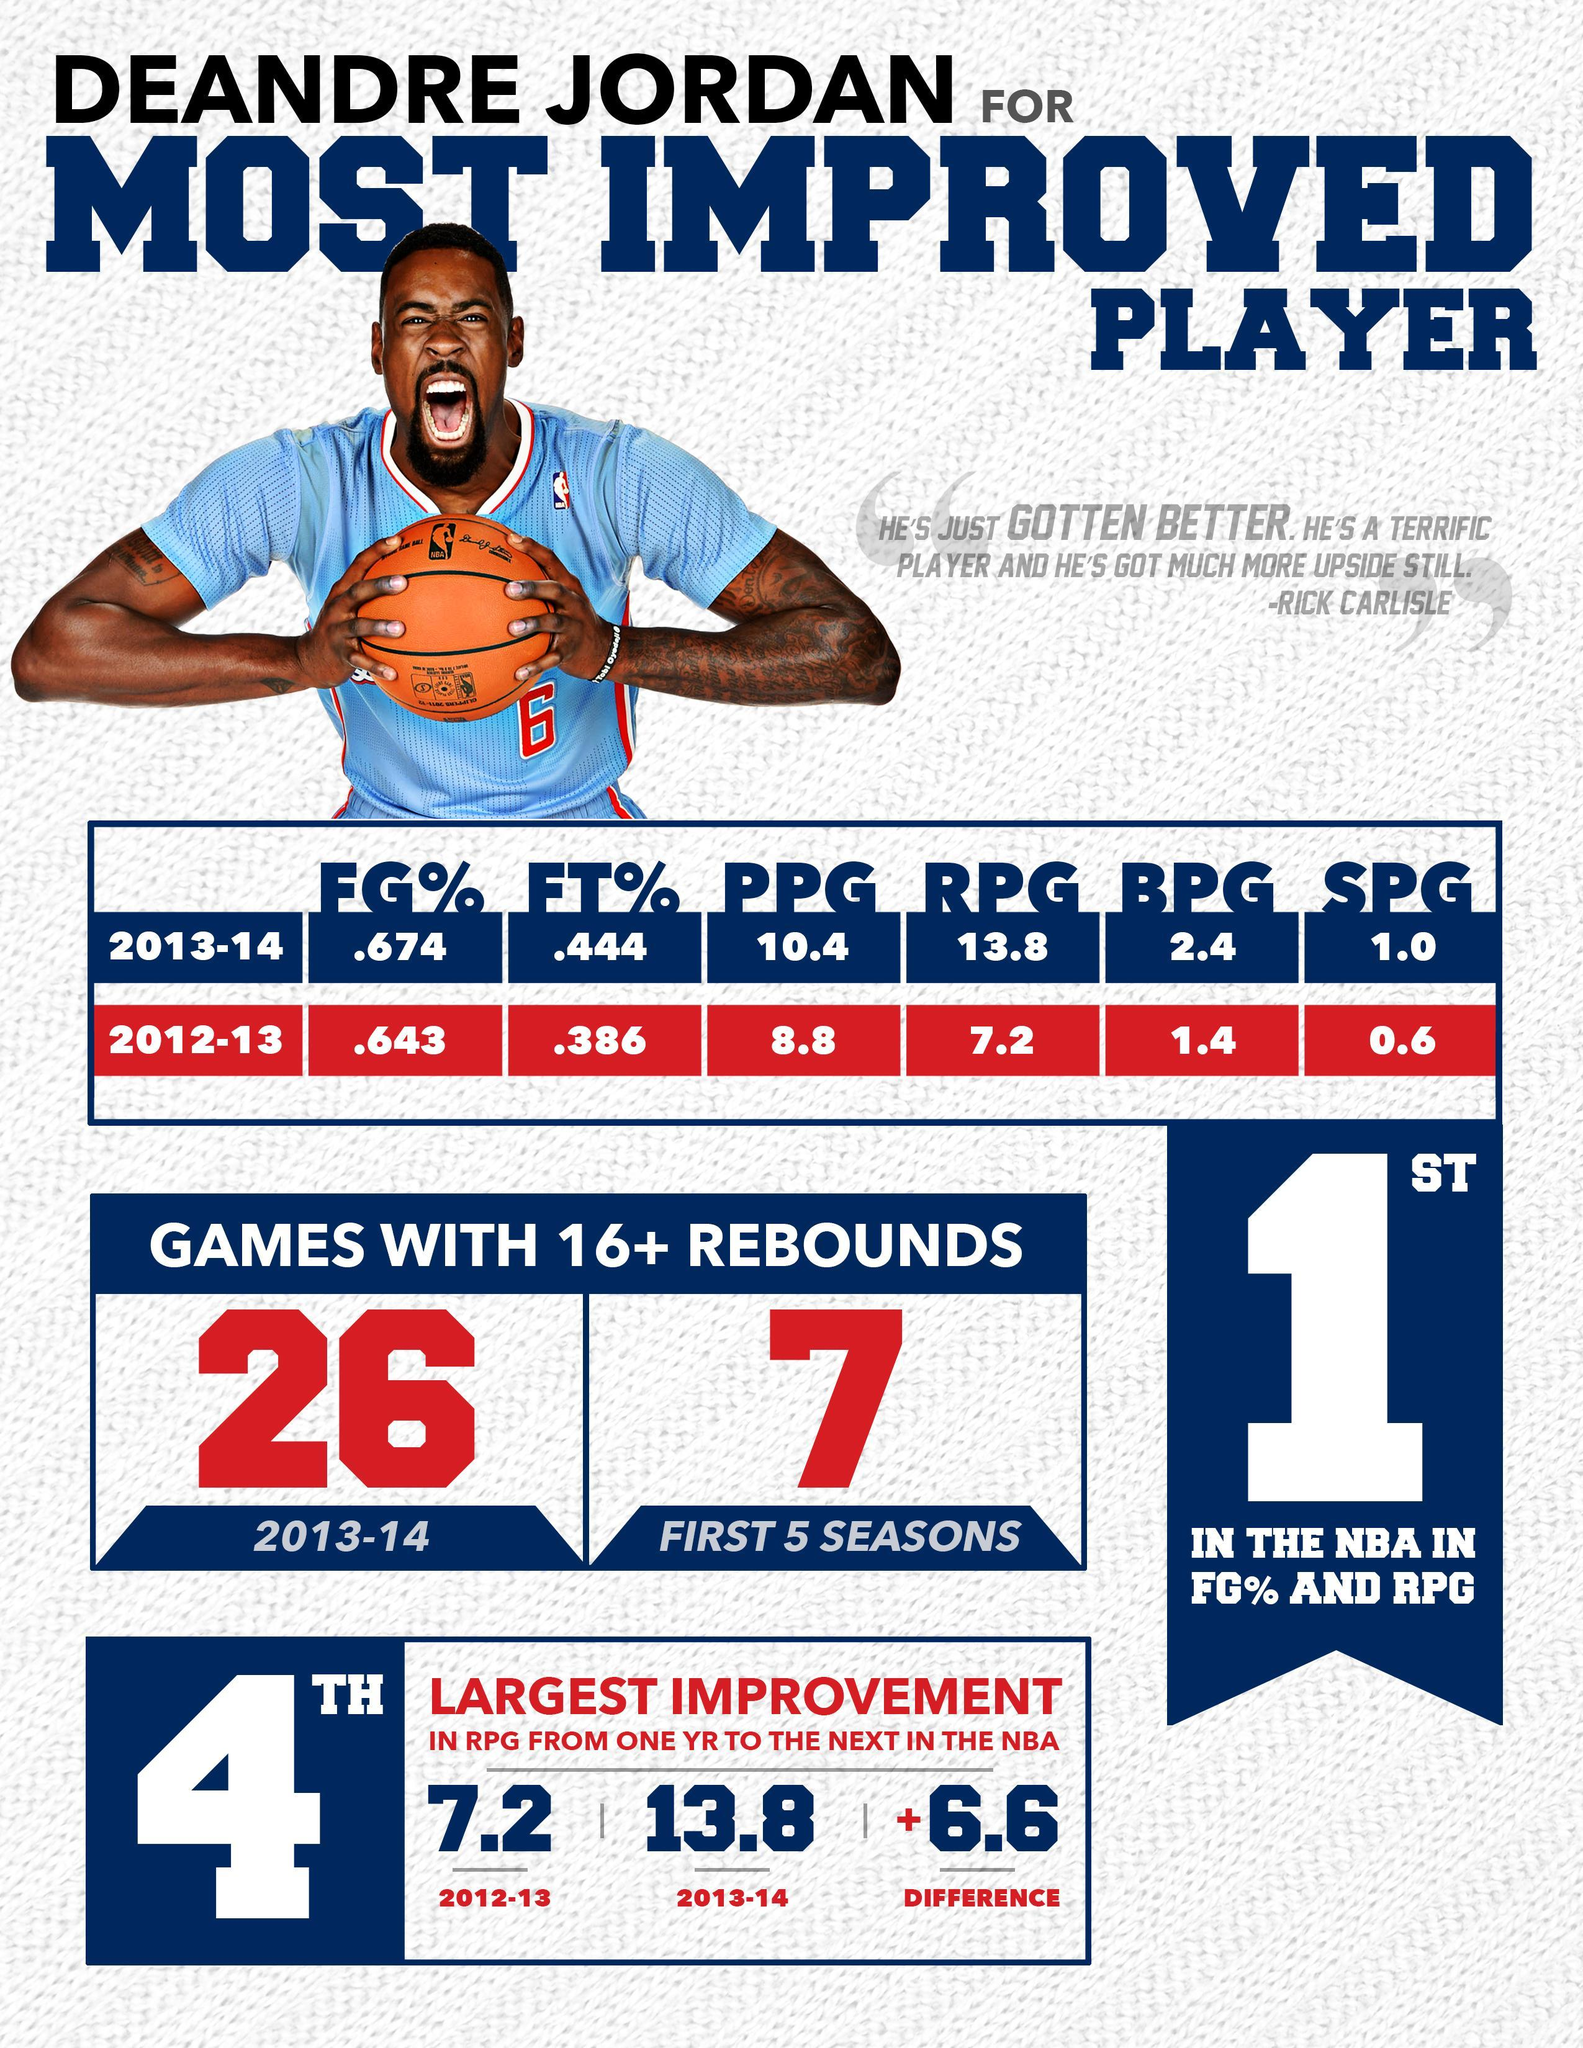What is the percentage of FG and FT, taken together in 2013-2014?
Answer the question with a short phrase. 1.118 What is the percentage of FG and FT, taken together in 2012-2013? 1.029 